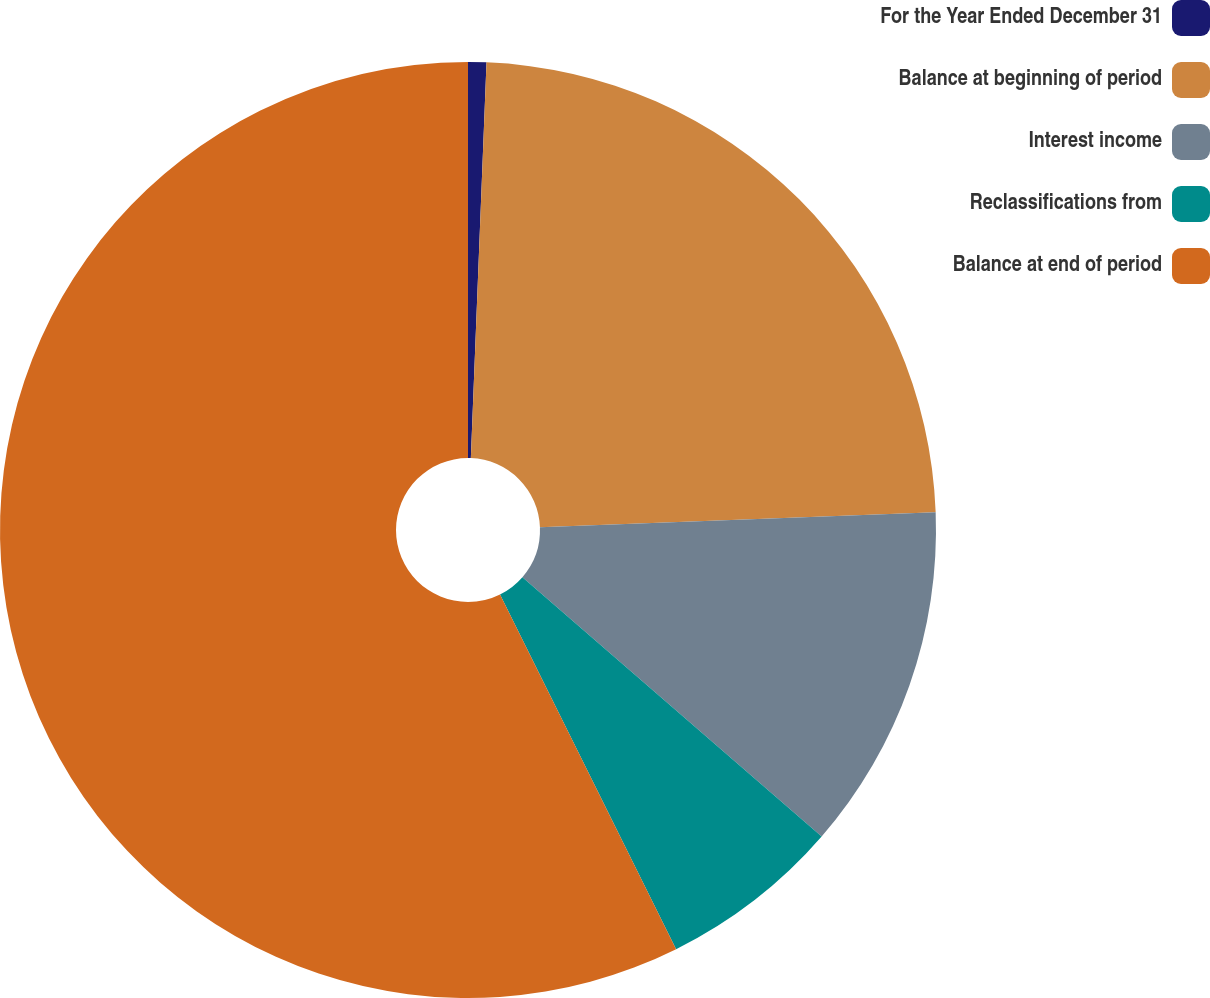Convert chart to OTSL. <chart><loc_0><loc_0><loc_500><loc_500><pie_chart><fcel>For the Year Ended December 31<fcel>Balance at beginning of period<fcel>Interest income<fcel>Reclassifications from<fcel>Balance at end of period<nl><fcel>0.63%<fcel>23.77%<fcel>11.97%<fcel>6.3%<fcel>57.34%<nl></chart> 